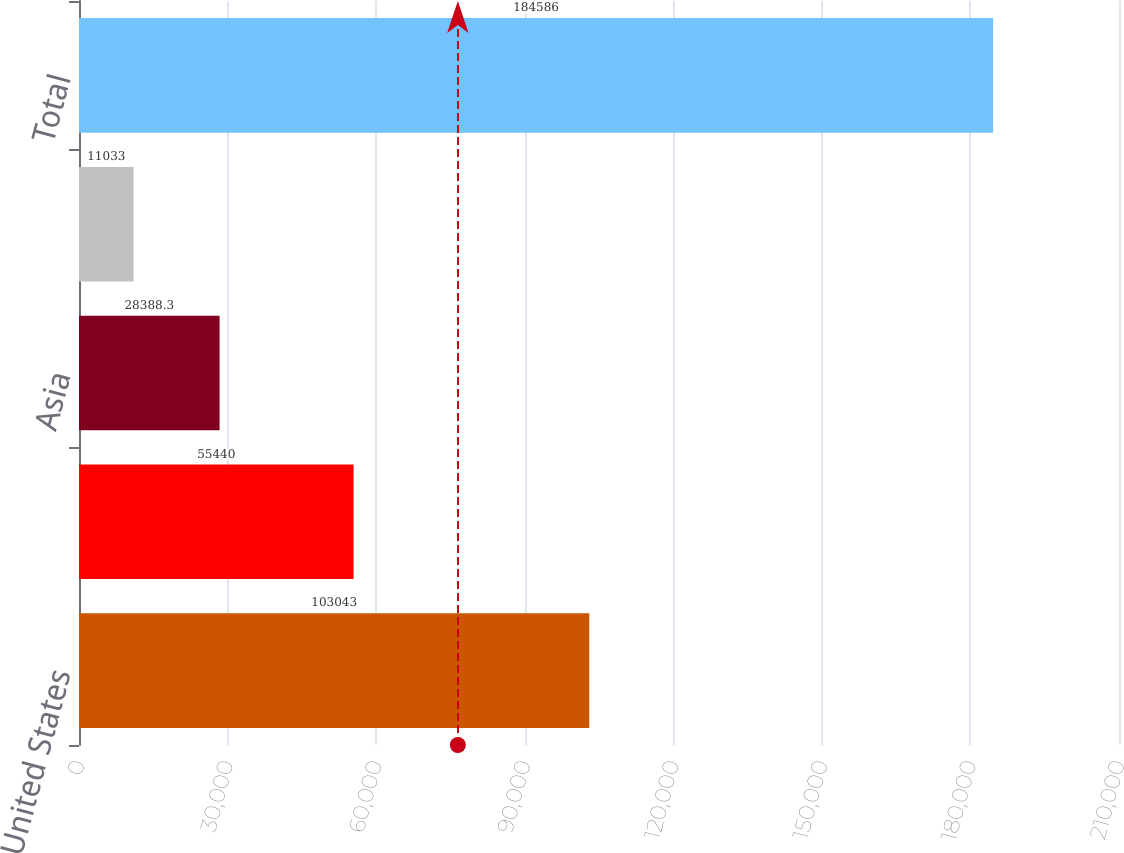Convert chart. <chart><loc_0><loc_0><loc_500><loc_500><bar_chart><fcel>United States<fcel>Europe<fcel>Asia<fcel>Other<fcel>Total<nl><fcel>103043<fcel>55440<fcel>28388.3<fcel>11033<fcel>184586<nl></chart> 